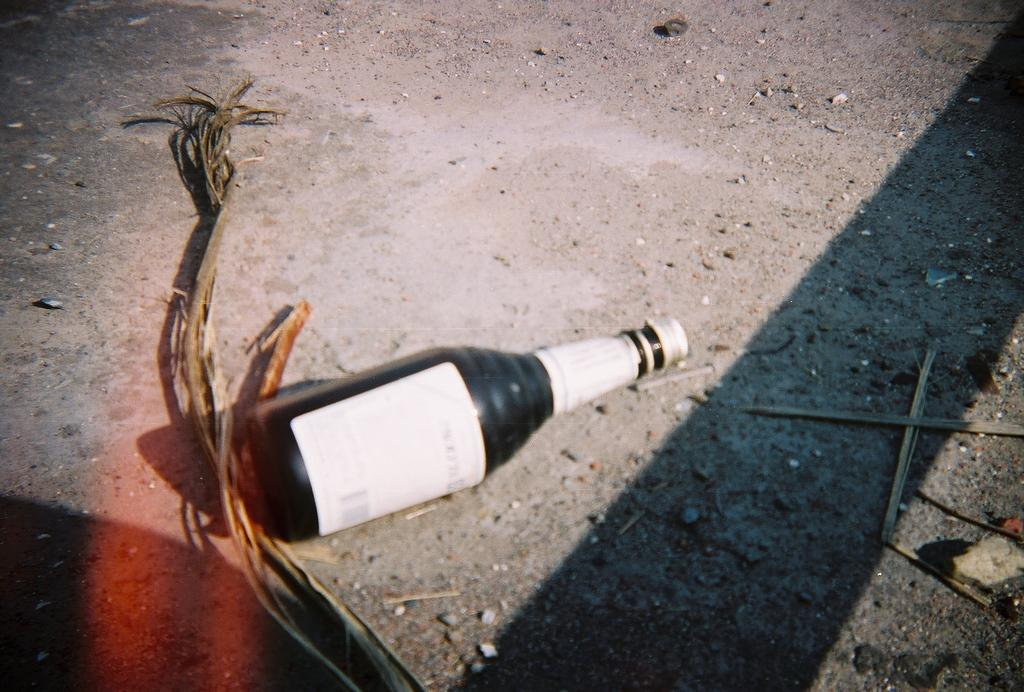What object can be seen on the floor in the image? There is a bottle on the floor in the image. What is the color of the bottle? The bottle is black in color. How does the van push the bottle in the image? There is no van present in the image, so it cannot push the bottle. 